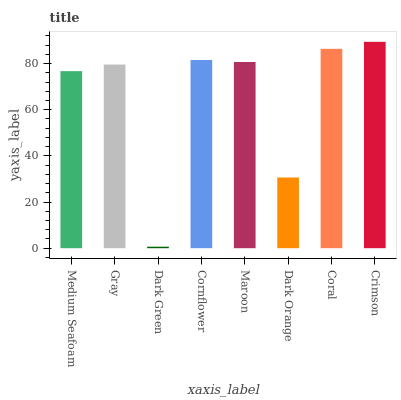Is Gray the minimum?
Answer yes or no. No. Is Gray the maximum?
Answer yes or no. No. Is Gray greater than Medium Seafoam?
Answer yes or no. Yes. Is Medium Seafoam less than Gray?
Answer yes or no. Yes. Is Medium Seafoam greater than Gray?
Answer yes or no. No. Is Gray less than Medium Seafoam?
Answer yes or no. No. Is Maroon the high median?
Answer yes or no. Yes. Is Gray the low median?
Answer yes or no. Yes. Is Gray the high median?
Answer yes or no. No. Is Maroon the low median?
Answer yes or no. No. 